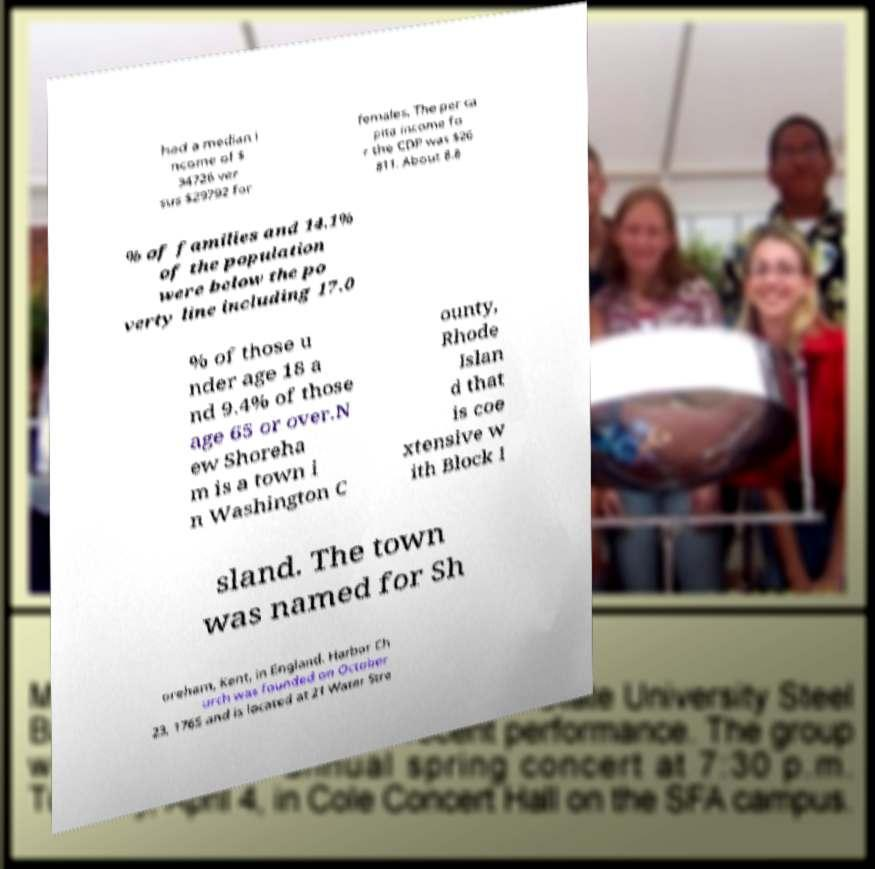What messages or text are displayed in this image? I need them in a readable, typed format. had a median i ncome of $ 34726 ver sus $29792 for females. The per ca pita income fo r the CDP was $26 811. About 8.8 % of families and 14.1% of the population were below the po verty line including 17.0 % of those u nder age 18 a nd 9.4% of those age 65 or over.N ew Shoreha m is a town i n Washington C ounty, Rhode Islan d that is coe xtensive w ith Block I sland. The town was named for Sh oreham, Kent, in England. Harbor Ch urch was founded on October 23, 1765 and is located at 21 Water Stre 